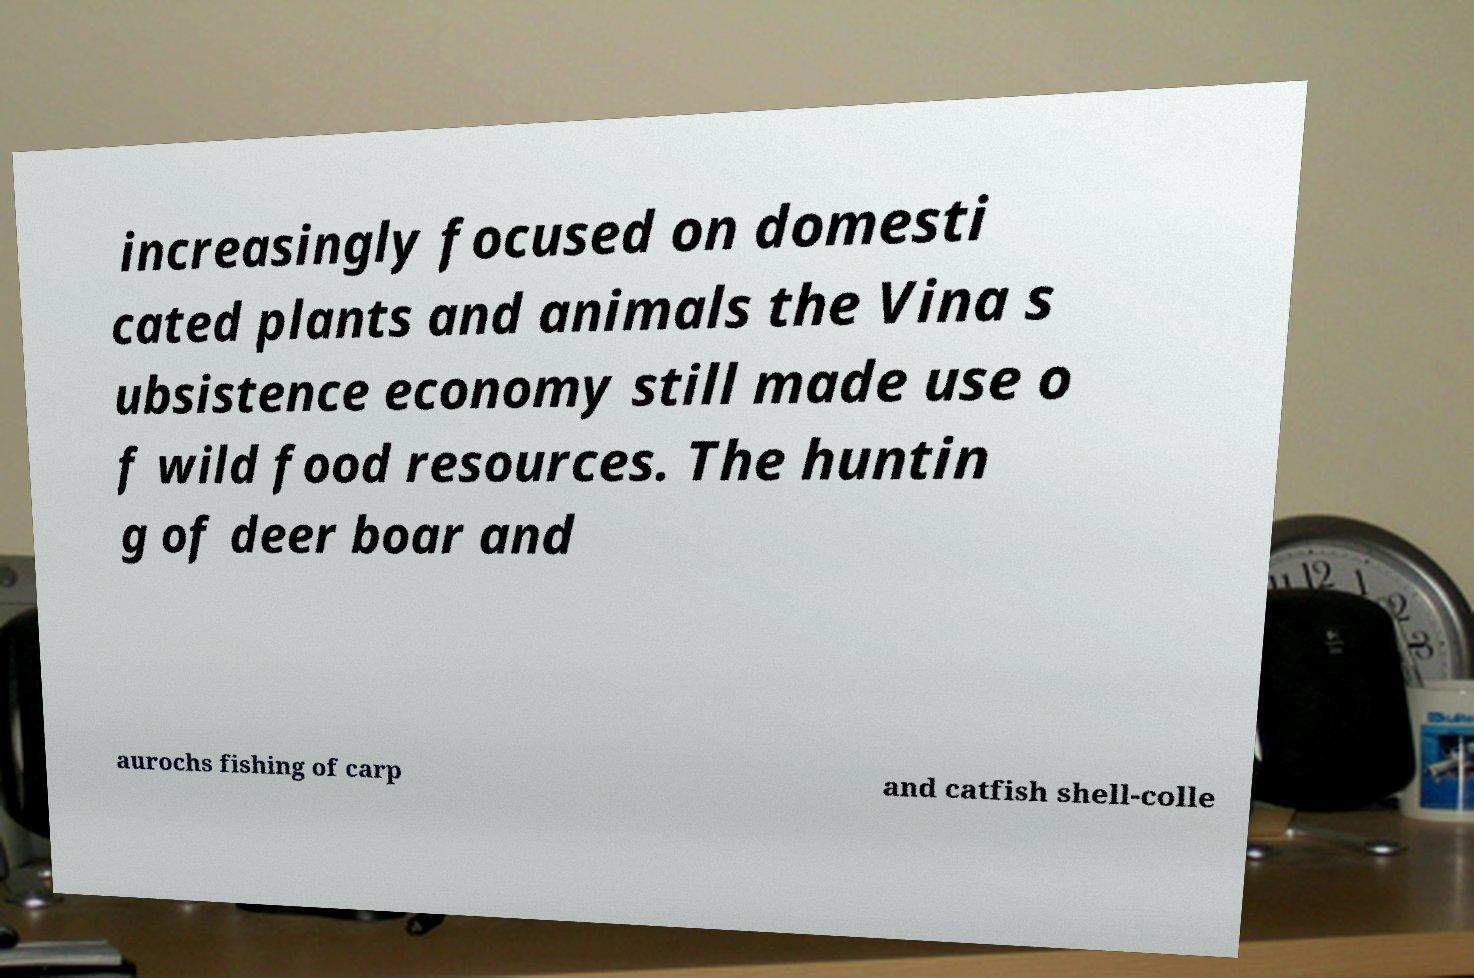Please read and relay the text visible in this image. What does it say? increasingly focused on domesti cated plants and animals the Vina s ubsistence economy still made use o f wild food resources. The huntin g of deer boar and aurochs fishing of carp and catfish shell-colle 